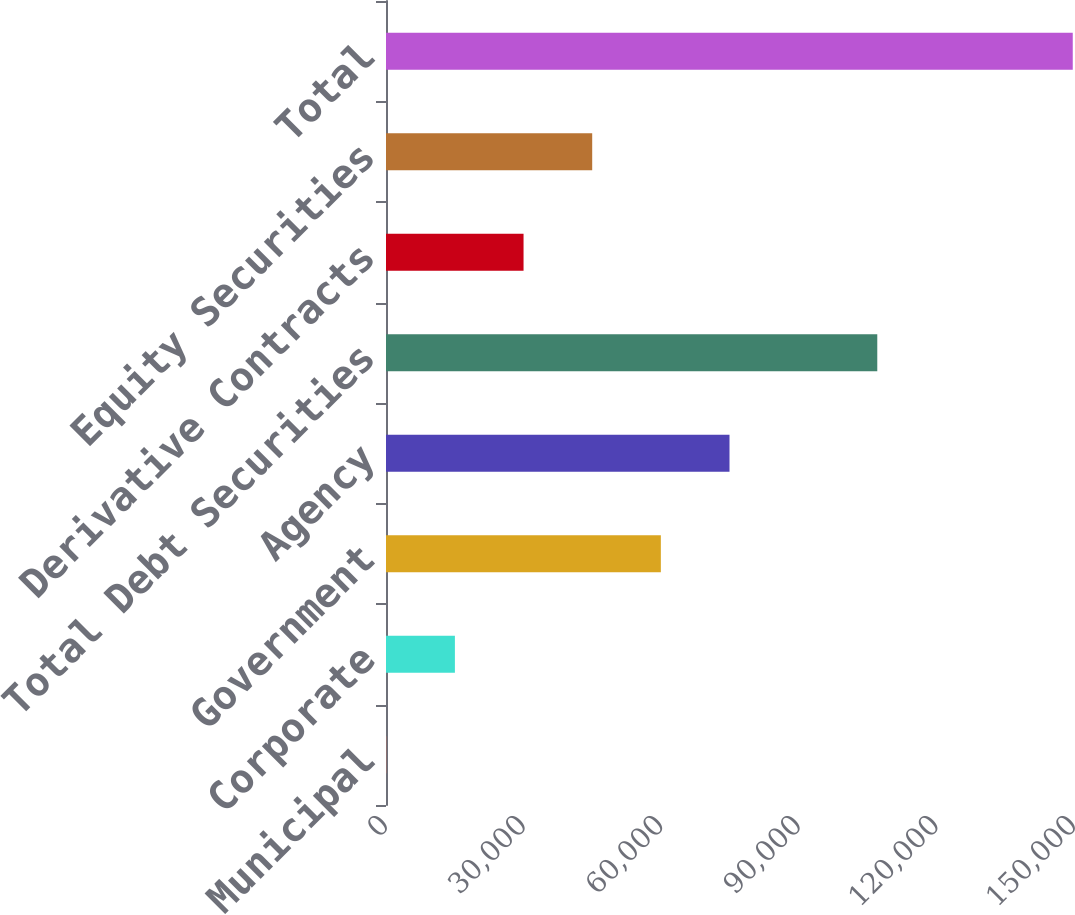Convert chart to OTSL. <chart><loc_0><loc_0><loc_500><loc_500><bar_chart><fcel>Municipal<fcel>Corporate<fcel>Government<fcel>Agency<fcel>Total Debt Securities<fcel>Derivative Contracts<fcel>Equity Securities<fcel>Total<nl><fcel>54<fcel>15021.5<fcel>59924<fcel>74891.5<fcel>107110<fcel>29989<fcel>44956.5<fcel>149729<nl></chart> 